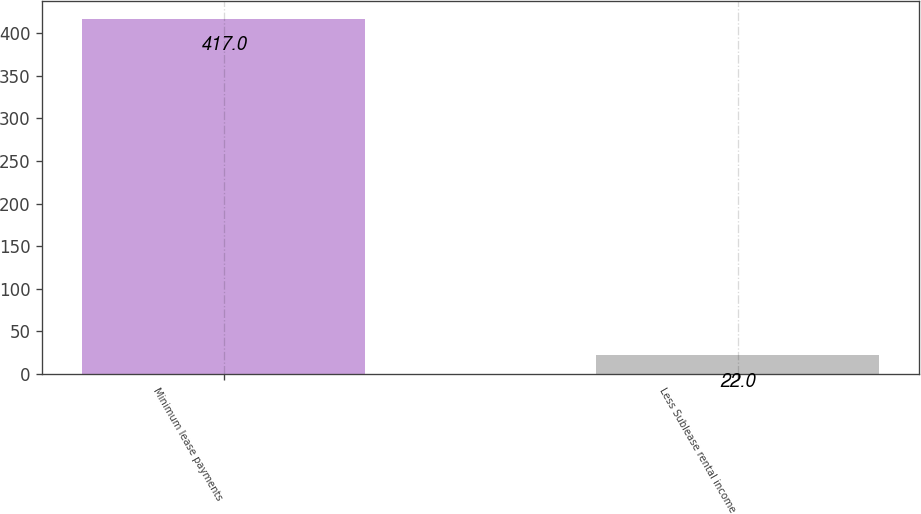Convert chart. <chart><loc_0><loc_0><loc_500><loc_500><bar_chart><fcel>Minimum lease payments<fcel>Less Sublease rental income<nl><fcel>417<fcel>22<nl></chart> 